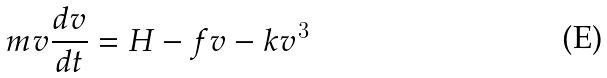<formula> <loc_0><loc_0><loc_500><loc_500>m v \frac { d v } { d t } = H - f v - k v ^ { 3 }</formula> 